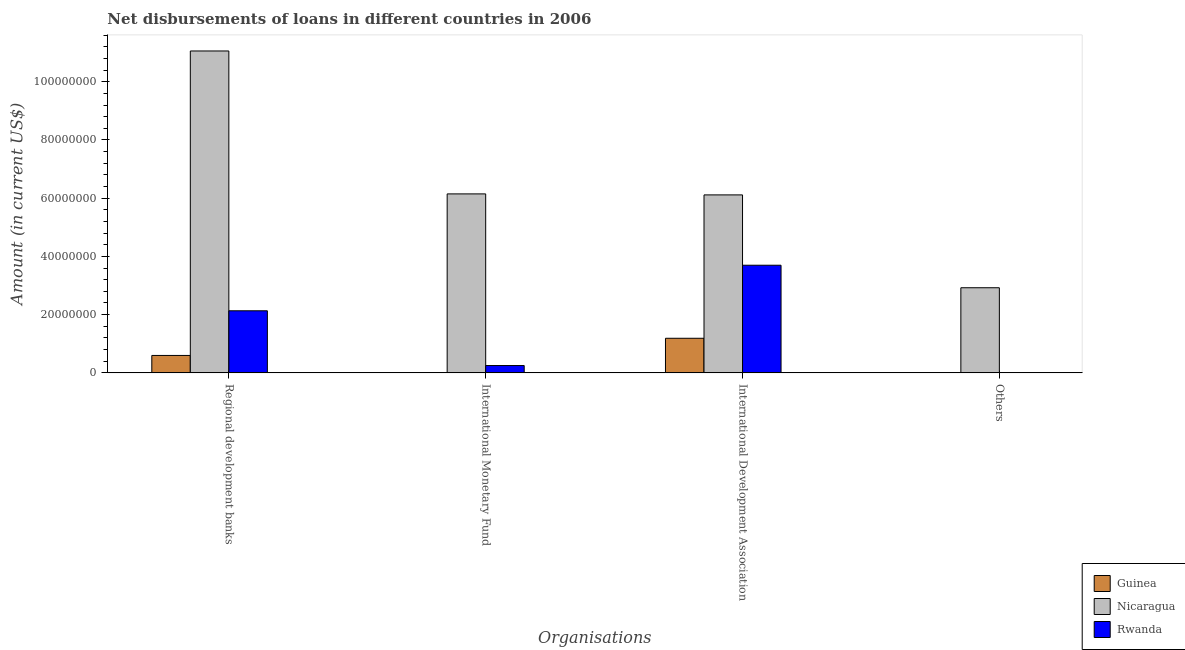How many different coloured bars are there?
Offer a very short reply. 3. Are the number of bars per tick equal to the number of legend labels?
Offer a very short reply. No. Are the number of bars on each tick of the X-axis equal?
Ensure brevity in your answer.  No. How many bars are there on the 2nd tick from the right?
Give a very brief answer. 3. What is the label of the 3rd group of bars from the left?
Provide a succinct answer. International Development Association. What is the amount of loan disimbursed by regional development banks in Rwanda?
Offer a terse response. 2.13e+07. Across all countries, what is the maximum amount of loan disimbursed by international monetary fund?
Offer a terse response. 6.15e+07. Across all countries, what is the minimum amount of loan disimbursed by international monetary fund?
Provide a short and direct response. 0. In which country was the amount of loan disimbursed by international monetary fund maximum?
Give a very brief answer. Nicaragua. What is the total amount of loan disimbursed by other organisations in the graph?
Ensure brevity in your answer.  2.92e+07. What is the difference between the amount of loan disimbursed by regional development banks in Nicaragua and that in Rwanda?
Offer a terse response. 8.92e+07. What is the difference between the amount of loan disimbursed by international development association in Nicaragua and the amount of loan disimbursed by other organisations in Rwanda?
Offer a terse response. 6.11e+07. What is the average amount of loan disimbursed by regional development banks per country?
Provide a succinct answer. 4.60e+07. What is the difference between the amount of loan disimbursed by international development association and amount of loan disimbursed by international monetary fund in Nicaragua?
Offer a terse response. -3.43e+05. What is the ratio of the amount of loan disimbursed by international development association in Nicaragua to that in Rwanda?
Your response must be concise. 1.65. What is the difference between the highest and the second highest amount of loan disimbursed by regional development banks?
Keep it short and to the point. 8.92e+07. What is the difference between the highest and the lowest amount of loan disimbursed by international monetary fund?
Give a very brief answer. 6.15e+07. Is it the case that in every country, the sum of the amount of loan disimbursed by other organisations and amount of loan disimbursed by international development association is greater than the sum of amount of loan disimbursed by international monetary fund and amount of loan disimbursed by regional development banks?
Offer a terse response. No. Does the graph contain any zero values?
Your response must be concise. Yes. Does the graph contain grids?
Provide a short and direct response. No. How many legend labels are there?
Your response must be concise. 3. What is the title of the graph?
Provide a succinct answer. Net disbursements of loans in different countries in 2006. Does "Korea (Democratic)" appear as one of the legend labels in the graph?
Your answer should be compact. No. What is the label or title of the X-axis?
Keep it short and to the point. Organisations. What is the Amount (in current US$) in Guinea in Regional development banks?
Ensure brevity in your answer.  5.98e+06. What is the Amount (in current US$) in Nicaragua in Regional development banks?
Provide a succinct answer. 1.11e+08. What is the Amount (in current US$) of Rwanda in Regional development banks?
Your response must be concise. 2.13e+07. What is the Amount (in current US$) of Nicaragua in International Monetary Fund?
Provide a short and direct response. 6.15e+07. What is the Amount (in current US$) of Rwanda in International Monetary Fund?
Your response must be concise. 2.52e+06. What is the Amount (in current US$) of Guinea in International Development Association?
Make the answer very short. 1.19e+07. What is the Amount (in current US$) of Nicaragua in International Development Association?
Offer a very short reply. 6.11e+07. What is the Amount (in current US$) of Rwanda in International Development Association?
Your response must be concise. 3.70e+07. What is the Amount (in current US$) in Nicaragua in Others?
Your answer should be very brief. 2.92e+07. Across all Organisations, what is the maximum Amount (in current US$) in Guinea?
Offer a very short reply. 1.19e+07. Across all Organisations, what is the maximum Amount (in current US$) in Nicaragua?
Offer a very short reply. 1.11e+08. Across all Organisations, what is the maximum Amount (in current US$) of Rwanda?
Keep it short and to the point. 3.70e+07. Across all Organisations, what is the minimum Amount (in current US$) of Nicaragua?
Provide a short and direct response. 2.92e+07. Across all Organisations, what is the minimum Amount (in current US$) in Rwanda?
Make the answer very short. 0. What is the total Amount (in current US$) of Guinea in the graph?
Provide a succinct answer. 1.79e+07. What is the total Amount (in current US$) in Nicaragua in the graph?
Your response must be concise. 2.62e+08. What is the total Amount (in current US$) of Rwanda in the graph?
Provide a short and direct response. 6.08e+07. What is the difference between the Amount (in current US$) of Nicaragua in Regional development banks and that in International Monetary Fund?
Make the answer very short. 4.91e+07. What is the difference between the Amount (in current US$) of Rwanda in Regional development banks and that in International Monetary Fund?
Provide a short and direct response. 1.88e+07. What is the difference between the Amount (in current US$) of Guinea in Regional development banks and that in International Development Association?
Offer a terse response. -5.90e+06. What is the difference between the Amount (in current US$) in Nicaragua in Regional development banks and that in International Development Association?
Offer a terse response. 4.94e+07. What is the difference between the Amount (in current US$) of Rwanda in Regional development banks and that in International Development Association?
Your answer should be compact. -1.56e+07. What is the difference between the Amount (in current US$) in Nicaragua in Regional development banks and that in Others?
Provide a short and direct response. 8.13e+07. What is the difference between the Amount (in current US$) of Nicaragua in International Monetary Fund and that in International Development Association?
Keep it short and to the point. 3.43e+05. What is the difference between the Amount (in current US$) of Rwanda in International Monetary Fund and that in International Development Association?
Ensure brevity in your answer.  -3.45e+07. What is the difference between the Amount (in current US$) of Nicaragua in International Monetary Fund and that in Others?
Provide a succinct answer. 3.22e+07. What is the difference between the Amount (in current US$) in Nicaragua in International Development Association and that in Others?
Make the answer very short. 3.19e+07. What is the difference between the Amount (in current US$) in Guinea in Regional development banks and the Amount (in current US$) in Nicaragua in International Monetary Fund?
Make the answer very short. -5.55e+07. What is the difference between the Amount (in current US$) of Guinea in Regional development banks and the Amount (in current US$) of Rwanda in International Monetary Fund?
Your answer should be very brief. 3.46e+06. What is the difference between the Amount (in current US$) in Nicaragua in Regional development banks and the Amount (in current US$) in Rwanda in International Monetary Fund?
Offer a terse response. 1.08e+08. What is the difference between the Amount (in current US$) of Guinea in Regional development banks and the Amount (in current US$) of Nicaragua in International Development Association?
Ensure brevity in your answer.  -5.51e+07. What is the difference between the Amount (in current US$) in Guinea in Regional development banks and the Amount (in current US$) in Rwanda in International Development Association?
Provide a short and direct response. -3.10e+07. What is the difference between the Amount (in current US$) in Nicaragua in Regional development banks and the Amount (in current US$) in Rwanda in International Development Association?
Provide a succinct answer. 7.36e+07. What is the difference between the Amount (in current US$) of Guinea in Regional development banks and the Amount (in current US$) of Nicaragua in Others?
Ensure brevity in your answer.  -2.33e+07. What is the difference between the Amount (in current US$) of Nicaragua in International Monetary Fund and the Amount (in current US$) of Rwanda in International Development Association?
Give a very brief answer. 2.45e+07. What is the difference between the Amount (in current US$) in Guinea in International Development Association and the Amount (in current US$) in Nicaragua in Others?
Offer a very short reply. -1.74e+07. What is the average Amount (in current US$) of Guinea per Organisations?
Your response must be concise. 4.47e+06. What is the average Amount (in current US$) of Nicaragua per Organisations?
Keep it short and to the point. 6.56e+07. What is the average Amount (in current US$) in Rwanda per Organisations?
Your answer should be very brief. 1.52e+07. What is the difference between the Amount (in current US$) in Guinea and Amount (in current US$) in Nicaragua in Regional development banks?
Your answer should be compact. -1.05e+08. What is the difference between the Amount (in current US$) in Guinea and Amount (in current US$) in Rwanda in Regional development banks?
Your answer should be very brief. -1.53e+07. What is the difference between the Amount (in current US$) of Nicaragua and Amount (in current US$) of Rwanda in Regional development banks?
Your response must be concise. 8.92e+07. What is the difference between the Amount (in current US$) in Nicaragua and Amount (in current US$) in Rwanda in International Monetary Fund?
Your response must be concise. 5.90e+07. What is the difference between the Amount (in current US$) in Guinea and Amount (in current US$) in Nicaragua in International Development Association?
Keep it short and to the point. -4.92e+07. What is the difference between the Amount (in current US$) of Guinea and Amount (in current US$) of Rwanda in International Development Association?
Give a very brief answer. -2.51e+07. What is the difference between the Amount (in current US$) in Nicaragua and Amount (in current US$) in Rwanda in International Development Association?
Provide a succinct answer. 2.42e+07. What is the ratio of the Amount (in current US$) in Nicaragua in Regional development banks to that in International Monetary Fund?
Your answer should be very brief. 1.8. What is the ratio of the Amount (in current US$) in Rwanda in Regional development banks to that in International Monetary Fund?
Your answer should be compact. 8.47. What is the ratio of the Amount (in current US$) of Guinea in Regional development banks to that in International Development Association?
Your answer should be compact. 0.5. What is the ratio of the Amount (in current US$) of Nicaragua in Regional development banks to that in International Development Association?
Your answer should be compact. 1.81. What is the ratio of the Amount (in current US$) in Rwanda in Regional development banks to that in International Development Association?
Your answer should be compact. 0.58. What is the ratio of the Amount (in current US$) of Nicaragua in Regional development banks to that in Others?
Give a very brief answer. 3.78. What is the ratio of the Amount (in current US$) of Nicaragua in International Monetary Fund to that in International Development Association?
Your response must be concise. 1.01. What is the ratio of the Amount (in current US$) of Rwanda in International Monetary Fund to that in International Development Association?
Your answer should be compact. 0.07. What is the ratio of the Amount (in current US$) in Nicaragua in International Monetary Fund to that in Others?
Provide a short and direct response. 2.1. What is the ratio of the Amount (in current US$) of Nicaragua in International Development Association to that in Others?
Provide a short and direct response. 2.09. What is the difference between the highest and the second highest Amount (in current US$) of Nicaragua?
Provide a succinct answer. 4.91e+07. What is the difference between the highest and the second highest Amount (in current US$) in Rwanda?
Give a very brief answer. 1.56e+07. What is the difference between the highest and the lowest Amount (in current US$) in Guinea?
Ensure brevity in your answer.  1.19e+07. What is the difference between the highest and the lowest Amount (in current US$) in Nicaragua?
Provide a short and direct response. 8.13e+07. What is the difference between the highest and the lowest Amount (in current US$) in Rwanda?
Your response must be concise. 3.70e+07. 